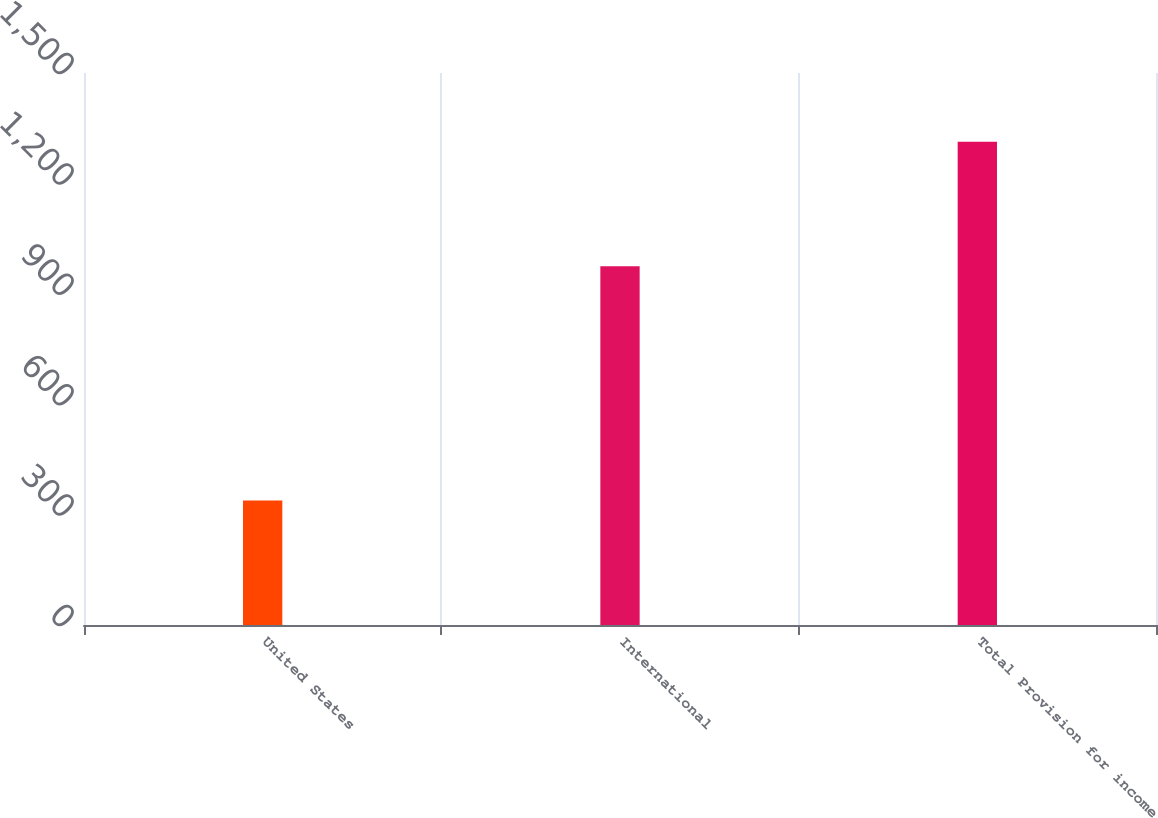<chart> <loc_0><loc_0><loc_500><loc_500><bar_chart><fcel>United States<fcel>International<fcel>Total Provision for income<nl><fcel>338<fcel>975<fcel>1313<nl></chart> 